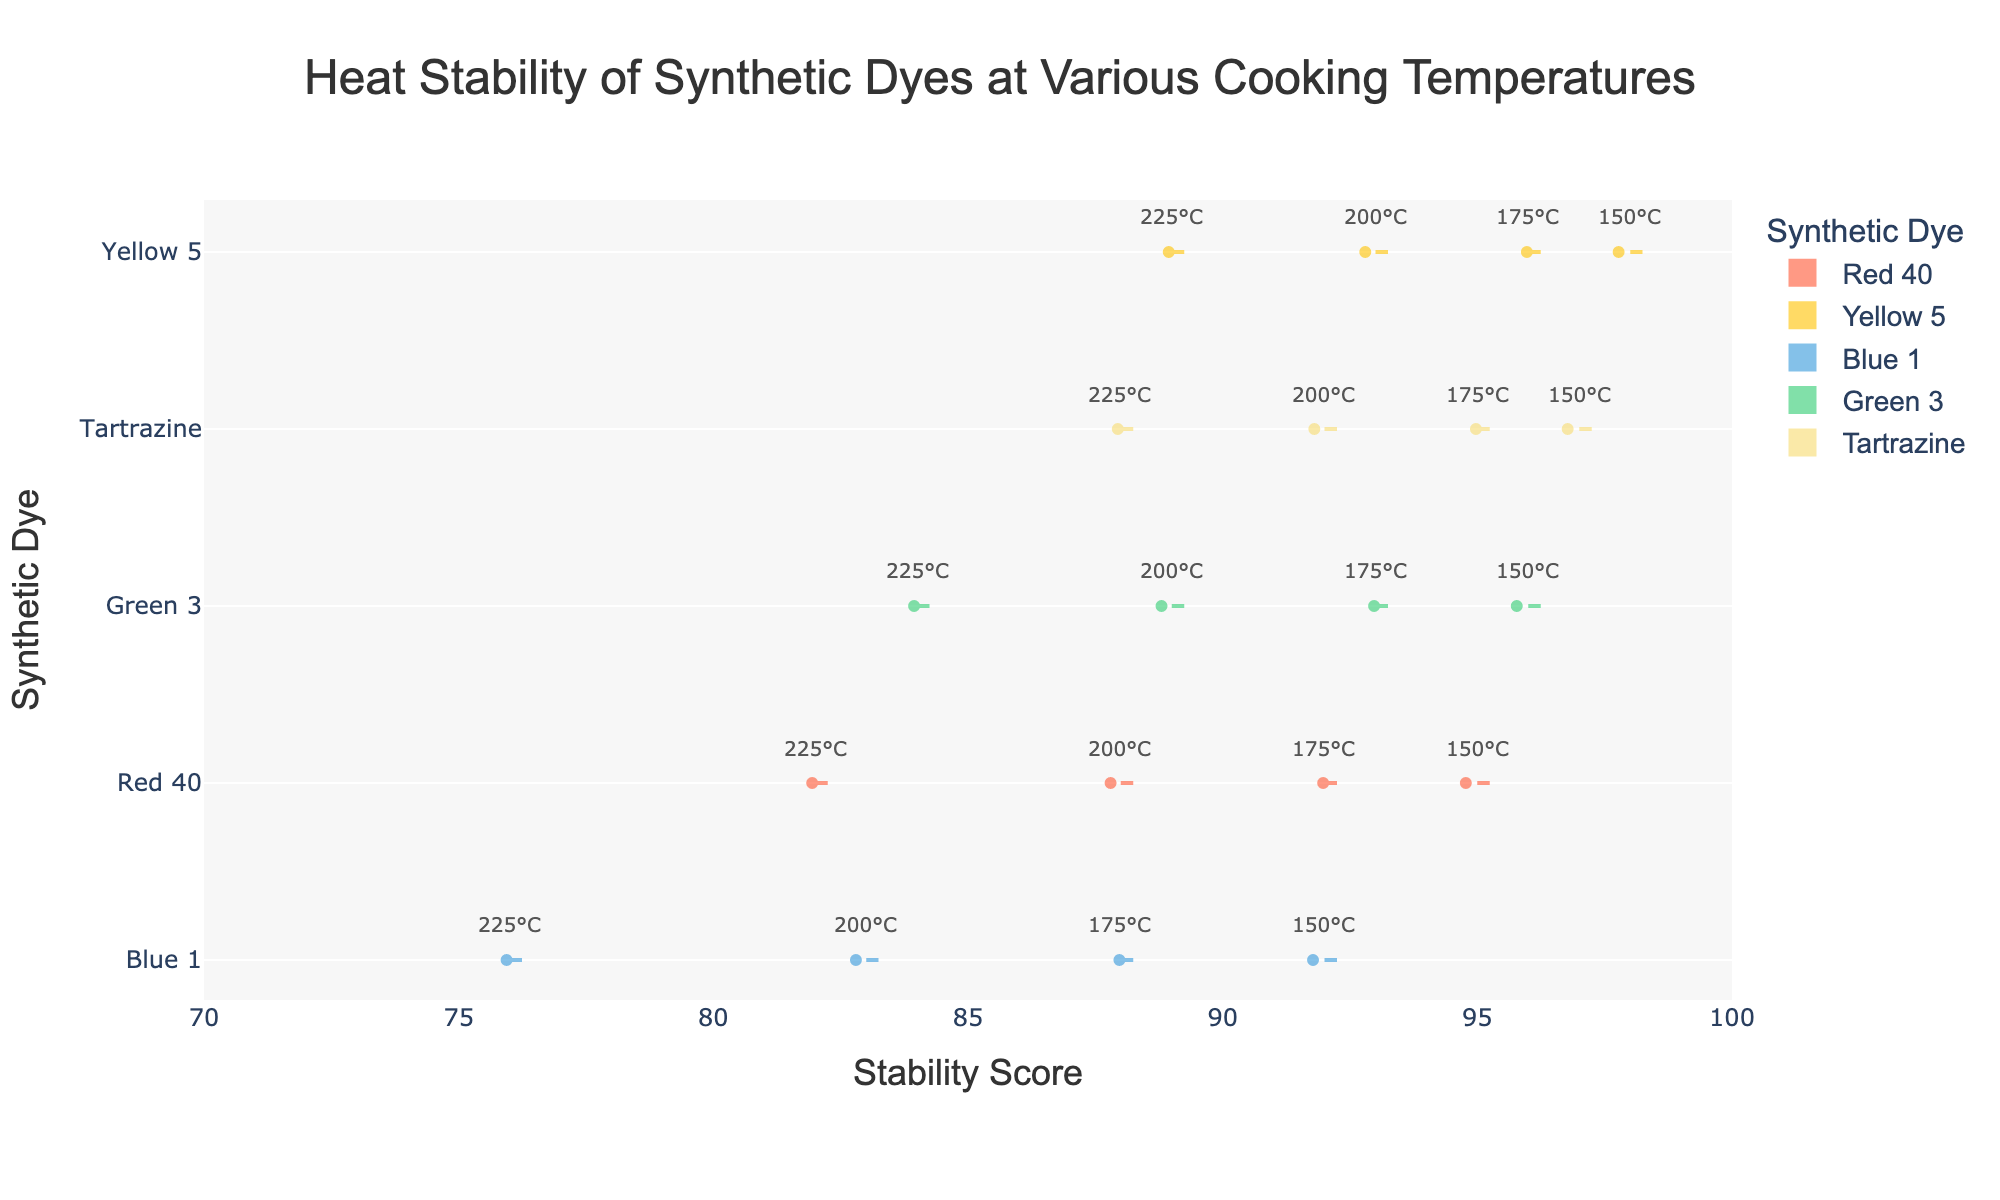What is the title of the figure? The title is clearly specified at the top of the figure.
Answer: Heat Stability of Synthetic Dyes at Various Cooking Temperatures How many dyes are compared in the figure? The figure shows five distinct categories on the y-axis, each representing a different dye.
Answer: 5 Which dye has the highest mean stability score? The figure uses meanline_visible to display the mean stability scores. The dye with the highest mean line is Yellow 5.
Answer: Yellow 5 At which temperature does Blue 1 show the lowest stability score? The annotated temperatures are linked to each stability score of Blue 1, and the lowest score is at 225°C.
Answer: 225°C What is the range of stability scores for Green 3? The range of stability scores is the difference between the highest and lowest stability scores for Green 3, visible on the x-axis. The range is 96 to 84.
Answer: 12 Are there any dyes that have stability scores lower than 80 at any temperature? Scan the figure for any data points below the 80 mark on the x-axis. Blue 1 has scores below 80 at 225°C.
Answer: Yes Which dye shows the most variability in stability scores? The variability can be identified by the spread of the points and the size of the violin plot. Blue 1 shows the largest spread.
Answer: Blue 1 How does Red 40's stability change as temperature increases? Follow the annotations and points for Red 40; its stability score decreases as temperature increases from 150°C to 225°C.
Answer: It decreases Do any dyes have stability scores above 95 at all temperatures? Examine the stability scores across all temperatures. No dye consistently stays above 95 at all temperatures.
Answer: No At which temperature does Tartrazine exhibit its lowest stability score, and what is that score? Check the annotations for Tartrazine and locate the lowest point on the x-axis. It's 88 at 225°C.
Answer: 225°C, 88 